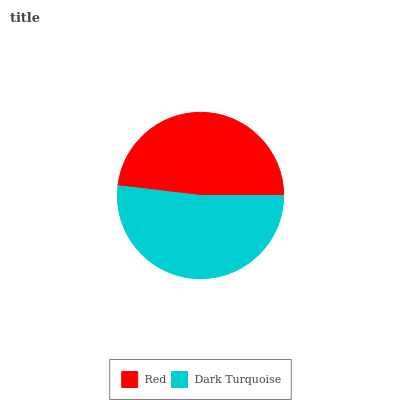Is Red the minimum?
Answer yes or no. Yes. Is Dark Turquoise the maximum?
Answer yes or no. Yes. Is Dark Turquoise the minimum?
Answer yes or no. No. Is Dark Turquoise greater than Red?
Answer yes or no. Yes. Is Red less than Dark Turquoise?
Answer yes or no. Yes. Is Red greater than Dark Turquoise?
Answer yes or no. No. Is Dark Turquoise less than Red?
Answer yes or no. No. Is Dark Turquoise the high median?
Answer yes or no. Yes. Is Red the low median?
Answer yes or no. Yes. Is Red the high median?
Answer yes or no. No. Is Dark Turquoise the low median?
Answer yes or no. No. 